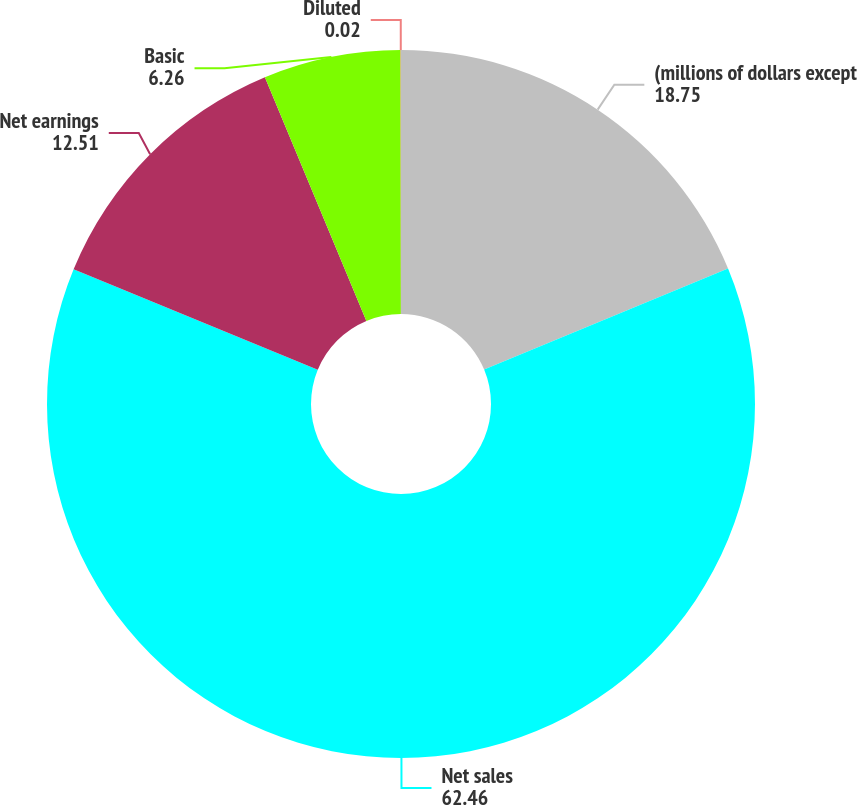Convert chart. <chart><loc_0><loc_0><loc_500><loc_500><pie_chart><fcel>(millions of dollars except<fcel>Net sales<fcel>Net earnings<fcel>Basic<fcel>Diluted<nl><fcel>18.75%<fcel>62.46%<fcel>12.51%<fcel>6.26%<fcel>0.02%<nl></chart> 